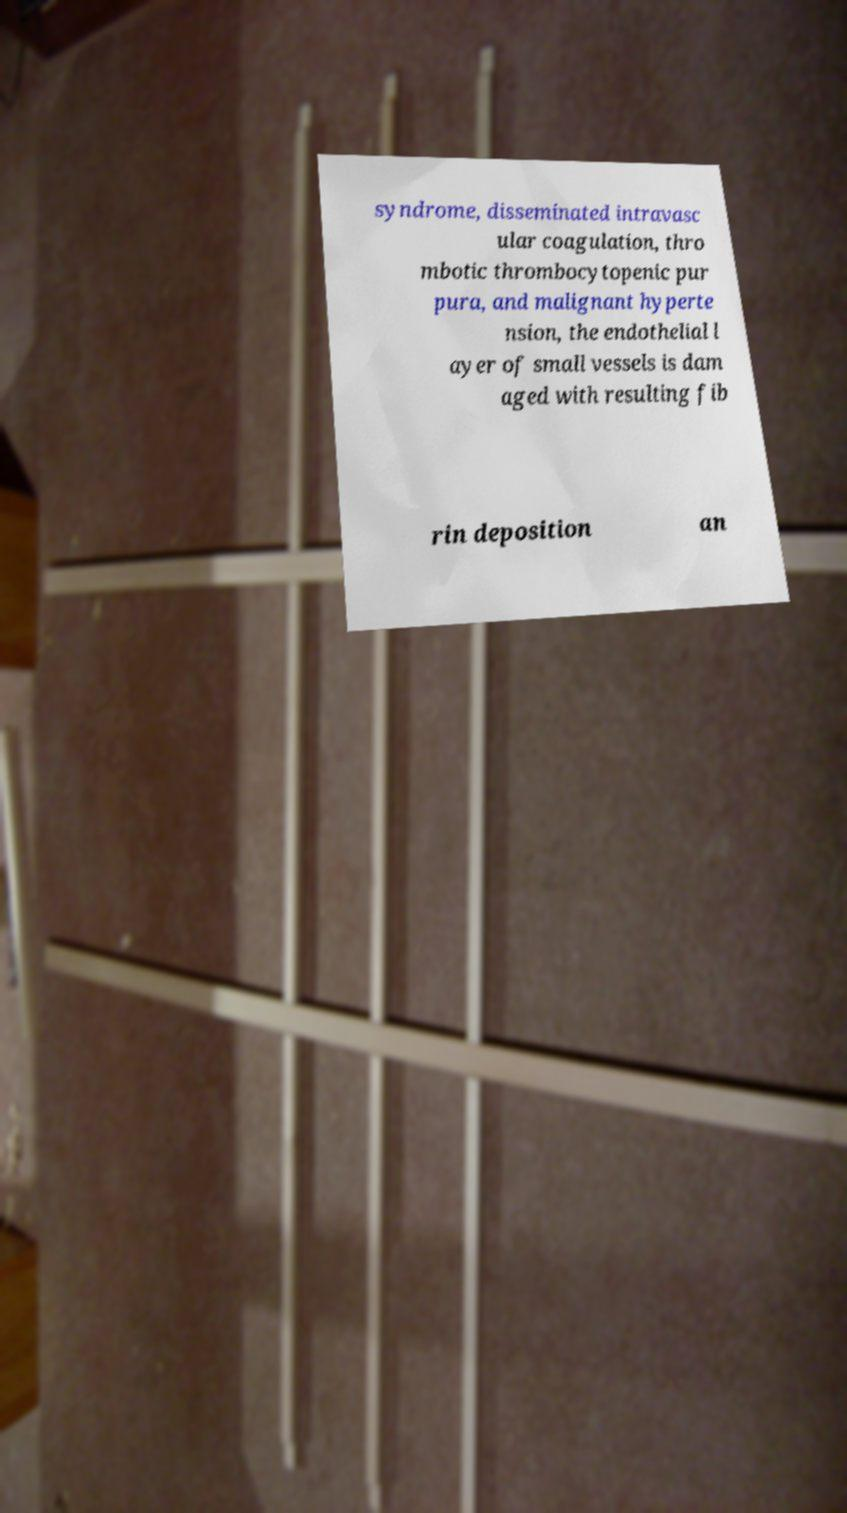For documentation purposes, I need the text within this image transcribed. Could you provide that? syndrome, disseminated intravasc ular coagulation, thro mbotic thrombocytopenic pur pura, and malignant hyperte nsion, the endothelial l ayer of small vessels is dam aged with resulting fib rin deposition an 